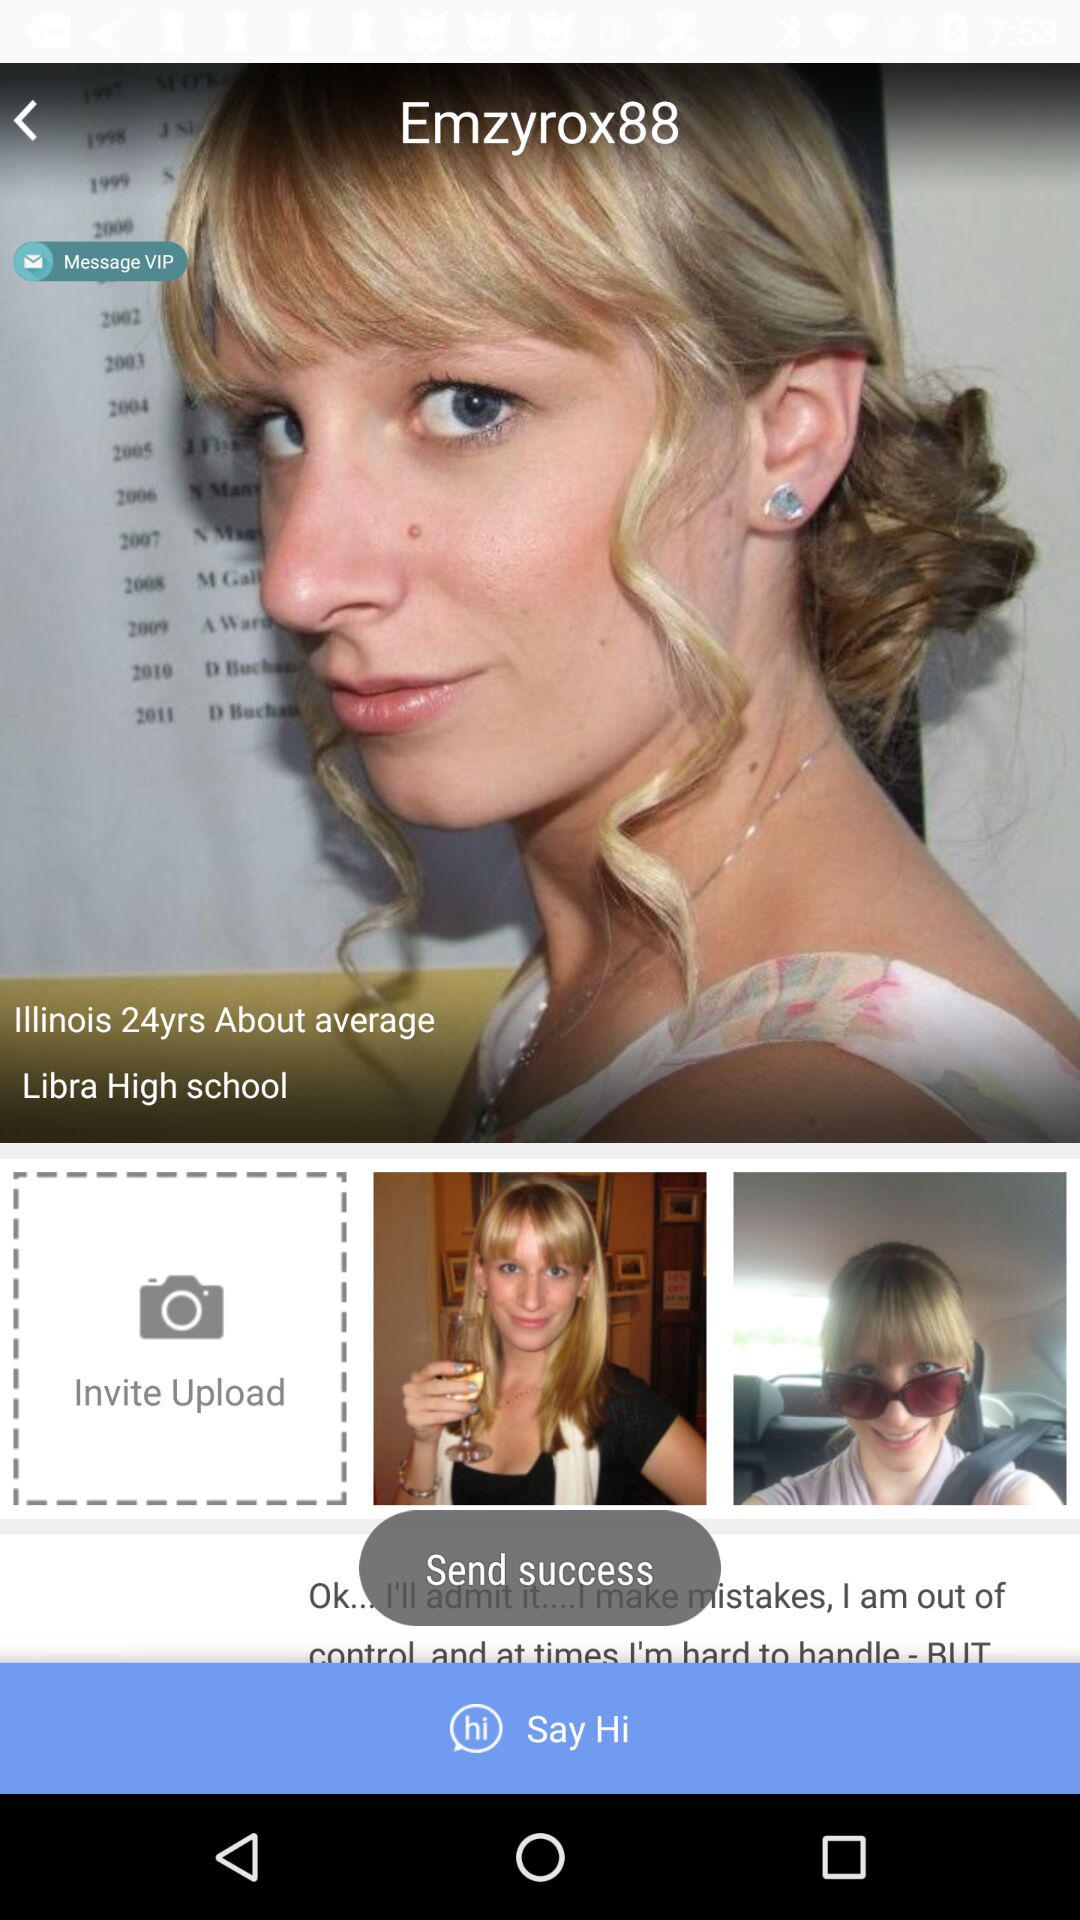At what school did Emzyrox study? Emzyrox studied at Libra High School. 